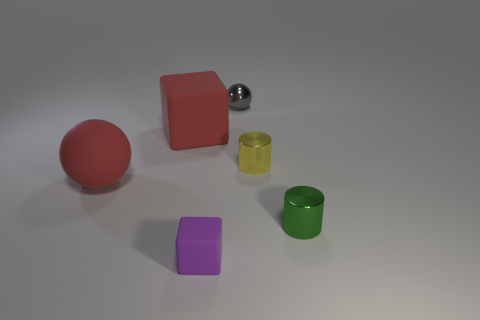Add 4 green objects. How many objects exist? 10 Subtract all cylinders. How many objects are left? 4 Add 3 small green metal cylinders. How many small green metal cylinders exist? 4 Subtract 0 brown blocks. How many objects are left? 6 Subtract all yellow metal cylinders. Subtract all gray metal balls. How many objects are left? 4 Add 4 rubber objects. How many rubber objects are left? 7 